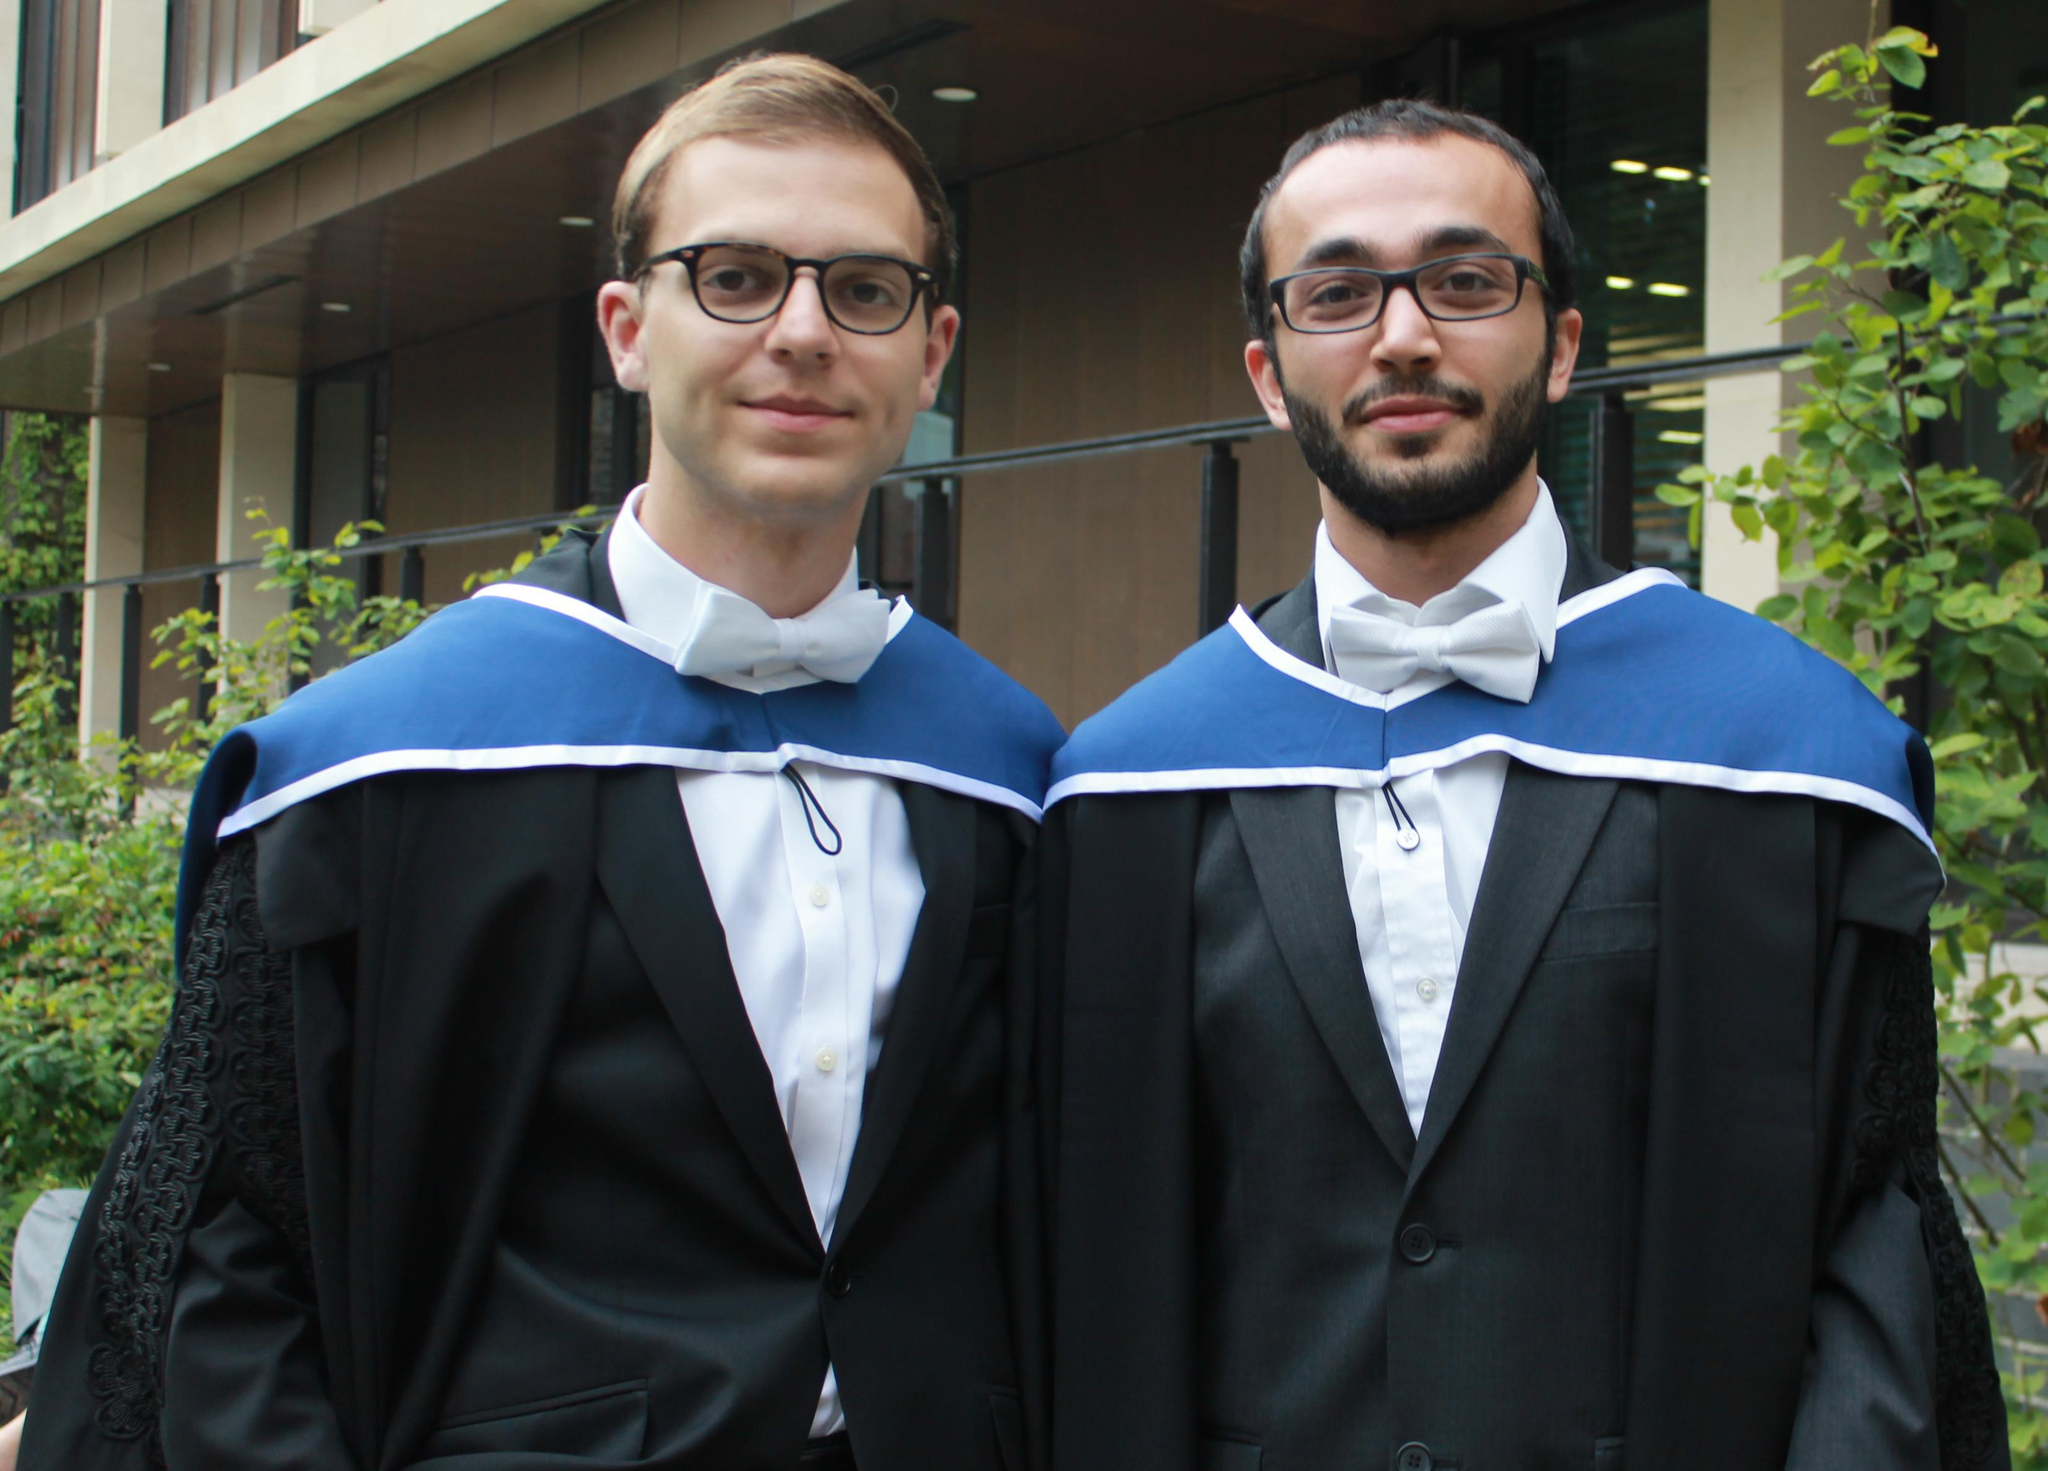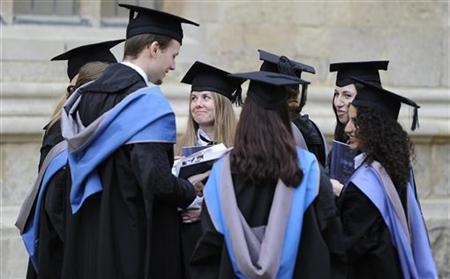The first image is the image on the left, the second image is the image on the right. Considering the images on both sides, is "There are two men with their shirts visible underneath there graduation gowns." valid? Answer yes or no. Yes. The first image is the image on the left, the second image is the image on the right. Considering the images on both sides, is "The image on the left does not contain more than two people." valid? Answer yes or no. Yes. 